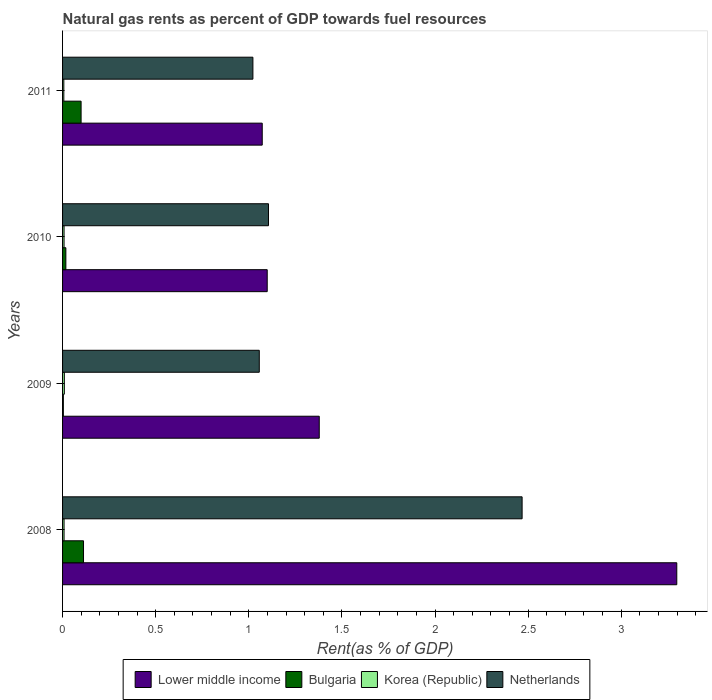How many groups of bars are there?
Offer a terse response. 4. Are the number of bars per tick equal to the number of legend labels?
Give a very brief answer. Yes. Are the number of bars on each tick of the Y-axis equal?
Give a very brief answer. Yes. How many bars are there on the 1st tick from the bottom?
Provide a short and direct response. 4. What is the matural gas rent in Bulgaria in 2009?
Your answer should be compact. 0. Across all years, what is the maximum matural gas rent in Lower middle income?
Make the answer very short. 3.3. Across all years, what is the minimum matural gas rent in Bulgaria?
Your answer should be very brief. 0. In which year was the matural gas rent in Korea (Republic) minimum?
Your answer should be compact. 2011. What is the total matural gas rent in Korea (Republic) in the graph?
Your answer should be compact. 0.03. What is the difference between the matural gas rent in Bulgaria in 2008 and that in 2011?
Keep it short and to the point. 0.01. What is the difference between the matural gas rent in Bulgaria in 2010 and the matural gas rent in Lower middle income in 2009?
Your answer should be very brief. -1.36. What is the average matural gas rent in Bulgaria per year?
Give a very brief answer. 0.06. In the year 2008, what is the difference between the matural gas rent in Lower middle income and matural gas rent in Netherlands?
Ensure brevity in your answer.  0.83. In how many years, is the matural gas rent in Netherlands greater than 1.6 %?
Ensure brevity in your answer.  1. What is the ratio of the matural gas rent in Netherlands in 2008 to that in 2009?
Your answer should be compact. 2.34. What is the difference between the highest and the second highest matural gas rent in Korea (Republic)?
Make the answer very short. 0. What is the difference between the highest and the lowest matural gas rent in Bulgaria?
Make the answer very short. 0.11. What does the 3rd bar from the bottom in 2009 represents?
Offer a terse response. Korea (Republic). Is it the case that in every year, the sum of the matural gas rent in Bulgaria and matural gas rent in Netherlands is greater than the matural gas rent in Lower middle income?
Your response must be concise. No. How many bars are there?
Your answer should be compact. 16. Are all the bars in the graph horizontal?
Your answer should be very brief. Yes. Are the values on the major ticks of X-axis written in scientific E-notation?
Make the answer very short. No. Does the graph contain any zero values?
Offer a very short reply. No. Where does the legend appear in the graph?
Offer a very short reply. Bottom center. How many legend labels are there?
Your response must be concise. 4. What is the title of the graph?
Provide a short and direct response. Natural gas rents as percent of GDP towards fuel resources. What is the label or title of the X-axis?
Keep it short and to the point. Rent(as % of GDP). What is the label or title of the Y-axis?
Your response must be concise. Years. What is the Rent(as % of GDP) of Lower middle income in 2008?
Your answer should be compact. 3.3. What is the Rent(as % of GDP) of Bulgaria in 2008?
Your answer should be compact. 0.11. What is the Rent(as % of GDP) in Korea (Republic) in 2008?
Your answer should be very brief. 0.01. What is the Rent(as % of GDP) in Netherlands in 2008?
Your answer should be very brief. 2.47. What is the Rent(as % of GDP) of Lower middle income in 2009?
Make the answer very short. 1.38. What is the Rent(as % of GDP) in Bulgaria in 2009?
Keep it short and to the point. 0. What is the Rent(as % of GDP) of Korea (Republic) in 2009?
Offer a terse response. 0.01. What is the Rent(as % of GDP) of Netherlands in 2009?
Make the answer very short. 1.06. What is the Rent(as % of GDP) of Lower middle income in 2010?
Provide a succinct answer. 1.1. What is the Rent(as % of GDP) in Bulgaria in 2010?
Your answer should be compact. 0.02. What is the Rent(as % of GDP) of Korea (Republic) in 2010?
Your response must be concise. 0.01. What is the Rent(as % of GDP) of Netherlands in 2010?
Ensure brevity in your answer.  1.11. What is the Rent(as % of GDP) in Lower middle income in 2011?
Provide a succinct answer. 1.07. What is the Rent(as % of GDP) in Bulgaria in 2011?
Keep it short and to the point. 0.1. What is the Rent(as % of GDP) in Korea (Republic) in 2011?
Make the answer very short. 0.01. What is the Rent(as % of GDP) in Netherlands in 2011?
Offer a terse response. 1.02. Across all years, what is the maximum Rent(as % of GDP) in Lower middle income?
Ensure brevity in your answer.  3.3. Across all years, what is the maximum Rent(as % of GDP) of Bulgaria?
Your answer should be very brief. 0.11. Across all years, what is the maximum Rent(as % of GDP) of Korea (Republic)?
Offer a very short reply. 0.01. Across all years, what is the maximum Rent(as % of GDP) of Netherlands?
Provide a short and direct response. 2.47. Across all years, what is the minimum Rent(as % of GDP) in Lower middle income?
Your answer should be very brief. 1.07. Across all years, what is the minimum Rent(as % of GDP) of Bulgaria?
Your answer should be very brief. 0. Across all years, what is the minimum Rent(as % of GDP) in Korea (Republic)?
Offer a terse response. 0.01. Across all years, what is the minimum Rent(as % of GDP) in Netherlands?
Your answer should be compact. 1.02. What is the total Rent(as % of GDP) in Lower middle income in the graph?
Ensure brevity in your answer.  6.85. What is the total Rent(as % of GDP) in Bulgaria in the graph?
Give a very brief answer. 0.23. What is the total Rent(as % of GDP) in Korea (Republic) in the graph?
Keep it short and to the point. 0.03. What is the total Rent(as % of GDP) of Netherlands in the graph?
Offer a very short reply. 5.65. What is the difference between the Rent(as % of GDP) of Lower middle income in 2008 and that in 2009?
Your answer should be very brief. 1.92. What is the difference between the Rent(as % of GDP) in Bulgaria in 2008 and that in 2009?
Provide a succinct answer. 0.11. What is the difference between the Rent(as % of GDP) of Korea (Republic) in 2008 and that in 2009?
Your answer should be very brief. -0. What is the difference between the Rent(as % of GDP) of Netherlands in 2008 and that in 2009?
Provide a short and direct response. 1.41. What is the difference between the Rent(as % of GDP) of Lower middle income in 2008 and that in 2010?
Provide a succinct answer. 2.2. What is the difference between the Rent(as % of GDP) of Bulgaria in 2008 and that in 2010?
Your answer should be very brief. 0.09. What is the difference between the Rent(as % of GDP) in Netherlands in 2008 and that in 2010?
Ensure brevity in your answer.  1.36. What is the difference between the Rent(as % of GDP) of Lower middle income in 2008 and that in 2011?
Your answer should be very brief. 2.23. What is the difference between the Rent(as % of GDP) in Bulgaria in 2008 and that in 2011?
Give a very brief answer. 0.01. What is the difference between the Rent(as % of GDP) in Korea (Republic) in 2008 and that in 2011?
Provide a succinct answer. 0. What is the difference between the Rent(as % of GDP) in Netherlands in 2008 and that in 2011?
Keep it short and to the point. 1.45. What is the difference between the Rent(as % of GDP) in Lower middle income in 2009 and that in 2010?
Make the answer very short. 0.28. What is the difference between the Rent(as % of GDP) of Bulgaria in 2009 and that in 2010?
Offer a terse response. -0.01. What is the difference between the Rent(as % of GDP) of Korea (Republic) in 2009 and that in 2010?
Provide a succinct answer. 0. What is the difference between the Rent(as % of GDP) of Netherlands in 2009 and that in 2010?
Your answer should be very brief. -0.05. What is the difference between the Rent(as % of GDP) of Lower middle income in 2009 and that in 2011?
Provide a succinct answer. 0.31. What is the difference between the Rent(as % of GDP) of Bulgaria in 2009 and that in 2011?
Your answer should be very brief. -0.1. What is the difference between the Rent(as % of GDP) in Korea (Republic) in 2009 and that in 2011?
Give a very brief answer. 0. What is the difference between the Rent(as % of GDP) of Netherlands in 2009 and that in 2011?
Ensure brevity in your answer.  0.03. What is the difference between the Rent(as % of GDP) of Lower middle income in 2010 and that in 2011?
Give a very brief answer. 0.03. What is the difference between the Rent(as % of GDP) in Bulgaria in 2010 and that in 2011?
Your answer should be compact. -0.08. What is the difference between the Rent(as % of GDP) in Korea (Republic) in 2010 and that in 2011?
Offer a very short reply. 0. What is the difference between the Rent(as % of GDP) of Netherlands in 2010 and that in 2011?
Provide a succinct answer. 0.08. What is the difference between the Rent(as % of GDP) of Lower middle income in 2008 and the Rent(as % of GDP) of Bulgaria in 2009?
Your answer should be compact. 3.29. What is the difference between the Rent(as % of GDP) of Lower middle income in 2008 and the Rent(as % of GDP) of Korea (Republic) in 2009?
Offer a very short reply. 3.29. What is the difference between the Rent(as % of GDP) of Lower middle income in 2008 and the Rent(as % of GDP) of Netherlands in 2009?
Make the answer very short. 2.24. What is the difference between the Rent(as % of GDP) of Bulgaria in 2008 and the Rent(as % of GDP) of Korea (Republic) in 2009?
Give a very brief answer. 0.1. What is the difference between the Rent(as % of GDP) of Bulgaria in 2008 and the Rent(as % of GDP) of Netherlands in 2009?
Ensure brevity in your answer.  -0.94. What is the difference between the Rent(as % of GDP) in Korea (Republic) in 2008 and the Rent(as % of GDP) in Netherlands in 2009?
Offer a terse response. -1.05. What is the difference between the Rent(as % of GDP) in Lower middle income in 2008 and the Rent(as % of GDP) in Bulgaria in 2010?
Your response must be concise. 3.28. What is the difference between the Rent(as % of GDP) of Lower middle income in 2008 and the Rent(as % of GDP) of Korea (Republic) in 2010?
Ensure brevity in your answer.  3.29. What is the difference between the Rent(as % of GDP) of Lower middle income in 2008 and the Rent(as % of GDP) of Netherlands in 2010?
Ensure brevity in your answer.  2.19. What is the difference between the Rent(as % of GDP) in Bulgaria in 2008 and the Rent(as % of GDP) in Korea (Republic) in 2010?
Offer a very short reply. 0.1. What is the difference between the Rent(as % of GDP) of Bulgaria in 2008 and the Rent(as % of GDP) of Netherlands in 2010?
Provide a short and direct response. -0.99. What is the difference between the Rent(as % of GDP) in Korea (Republic) in 2008 and the Rent(as % of GDP) in Netherlands in 2010?
Keep it short and to the point. -1.1. What is the difference between the Rent(as % of GDP) of Lower middle income in 2008 and the Rent(as % of GDP) of Bulgaria in 2011?
Keep it short and to the point. 3.2. What is the difference between the Rent(as % of GDP) in Lower middle income in 2008 and the Rent(as % of GDP) in Korea (Republic) in 2011?
Provide a short and direct response. 3.29. What is the difference between the Rent(as % of GDP) in Lower middle income in 2008 and the Rent(as % of GDP) in Netherlands in 2011?
Give a very brief answer. 2.28. What is the difference between the Rent(as % of GDP) in Bulgaria in 2008 and the Rent(as % of GDP) in Korea (Republic) in 2011?
Your response must be concise. 0.11. What is the difference between the Rent(as % of GDP) in Bulgaria in 2008 and the Rent(as % of GDP) in Netherlands in 2011?
Offer a very short reply. -0.91. What is the difference between the Rent(as % of GDP) of Korea (Republic) in 2008 and the Rent(as % of GDP) of Netherlands in 2011?
Give a very brief answer. -1.01. What is the difference between the Rent(as % of GDP) of Lower middle income in 2009 and the Rent(as % of GDP) of Bulgaria in 2010?
Your answer should be very brief. 1.36. What is the difference between the Rent(as % of GDP) of Lower middle income in 2009 and the Rent(as % of GDP) of Korea (Republic) in 2010?
Give a very brief answer. 1.37. What is the difference between the Rent(as % of GDP) in Lower middle income in 2009 and the Rent(as % of GDP) in Netherlands in 2010?
Keep it short and to the point. 0.27. What is the difference between the Rent(as % of GDP) in Bulgaria in 2009 and the Rent(as % of GDP) in Korea (Republic) in 2010?
Your response must be concise. -0. What is the difference between the Rent(as % of GDP) in Bulgaria in 2009 and the Rent(as % of GDP) in Netherlands in 2010?
Offer a very short reply. -1.1. What is the difference between the Rent(as % of GDP) in Korea (Republic) in 2009 and the Rent(as % of GDP) in Netherlands in 2010?
Your answer should be compact. -1.1. What is the difference between the Rent(as % of GDP) in Lower middle income in 2009 and the Rent(as % of GDP) in Bulgaria in 2011?
Make the answer very short. 1.28. What is the difference between the Rent(as % of GDP) of Lower middle income in 2009 and the Rent(as % of GDP) of Korea (Republic) in 2011?
Your response must be concise. 1.37. What is the difference between the Rent(as % of GDP) in Lower middle income in 2009 and the Rent(as % of GDP) in Netherlands in 2011?
Give a very brief answer. 0.36. What is the difference between the Rent(as % of GDP) in Bulgaria in 2009 and the Rent(as % of GDP) in Korea (Republic) in 2011?
Offer a terse response. -0. What is the difference between the Rent(as % of GDP) in Bulgaria in 2009 and the Rent(as % of GDP) in Netherlands in 2011?
Offer a very short reply. -1.02. What is the difference between the Rent(as % of GDP) of Korea (Republic) in 2009 and the Rent(as % of GDP) of Netherlands in 2011?
Make the answer very short. -1.01. What is the difference between the Rent(as % of GDP) in Lower middle income in 2010 and the Rent(as % of GDP) in Bulgaria in 2011?
Provide a succinct answer. 1. What is the difference between the Rent(as % of GDP) of Lower middle income in 2010 and the Rent(as % of GDP) of Korea (Republic) in 2011?
Provide a succinct answer. 1.09. What is the difference between the Rent(as % of GDP) in Lower middle income in 2010 and the Rent(as % of GDP) in Netherlands in 2011?
Your response must be concise. 0.08. What is the difference between the Rent(as % of GDP) in Bulgaria in 2010 and the Rent(as % of GDP) in Korea (Republic) in 2011?
Ensure brevity in your answer.  0.01. What is the difference between the Rent(as % of GDP) of Bulgaria in 2010 and the Rent(as % of GDP) of Netherlands in 2011?
Keep it short and to the point. -1. What is the difference between the Rent(as % of GDP) of Korea (Republic) in 2010 and the Rent(as % of GDP) of Netherlands in 2011?
Provide a succinct answer. -1.01. What is the average Rent(as % of GDP) of Lower middle income per year?
Offer a very short reply. 1.71. What is the average Rent(as % of GDP) of Bulgaria per year?
Keep it short and to the point. 0.06. What is the average Rent(as % of GDP) of Korea (Republic) per year?
Offer a very short reply. 0.01. What is the average Rent(as % of GDP) of Netherlands per year?
Offer a very short reply. 1.41. In the year 2008, what is the difference between the Rent(as % of GDP) of Lower middle income and Rent(as % of GDP) of Bulgaria?
Your answer should be compact. 3.19. In the year 2008, what is the difference between the Rent(as % of GDP) of Lower middle income and Rent(as % of GDP) of Korea (Republic)?
Make the answer very short. 3.29. In the year 2008, what is the difference between the Rent(as % of GDP) in Lower middle income and Rent(as % of GDP) in Netherlands?
Your response must be concise. 0.83. In the year 2008, what is the difference between the Rent(as % of GDP) of Bulgaria and Rent(as % of GDP) of Korea (Republic)?
Your answer should be very brief. 0.1. In the year 2008, what is the difference between the Rent(as % of GDP) of Bulgaria and Rent(as % of GDP) of Netherlands?
Keep it short and to the point. -2.36. In the year 2008, what is the difference between the Rent(as % of GDP) in Korea (Republic) and Rent(as % of GDP) in Netherlands?
Offer a terse response. -2.46. In the year 2009, what is the difference between the Rent(as % of GDP) in Lower middle income and Rent(as % of GDP) in Bulgaria?
Your answer should be very brief. 1.37. In the year 2009, what is the difference between the Rent(as % of GDP) in Lower middle income and Rent(as % of GDP) in Korea (Republic)?
Provide a short and direct response. 1.37. In the year 2009, what is the difference between the Rent(as % of GDP) of Lower middle income and Rent(as % of GDP) of Netherlands?
Keep it short and to the point. 0.32. In the year 2009, what is the difference between the Rent(as % of GDP) in Bulgaria and Rent(as % of GDP) in Korea (Republic)?
Ensure brevity in your answer.  -0.01. In the year 2009, what is the difference between the Rent(as % of GDP) in Bulgaria and Rent(as % of GDP) in Netherlands?
Your answer should be very brief. -1.05. In the year 2009, what is the difference between the Rent(as % of GDP) in Korea (Republic) and Rent(as % of GDP) in Netherlands?
Ensure brevity in your answer.  -1.05. In the year 2010, what is the difference between the Rent(as % of GDP) of Lower middle income and Rent(as % of GDP) of Bulgaria?
Provide a short and direct response. 1.08. In the year 2010, what is the difference between the Rent(as % of GDP) of Lower middle income and Rent(as % of GDP) of Netherlands?
Keep it short and to the point. -0.01. In the year 2010, what is the difference between the Rent(as % of GDP) in Bulgaria and Rent(as % of GDP) in Korea (Republic)?
Give a very brief answer. 0.01. In the year 2010, what is the difference between the Rent(as % of GDP) in Bulgaria and Rent(as % of GDP) in Netherlands?
Provide a short and direct response. -1.09. In the year 2010, what is the difference between the Rent(as % of GDP) of Korea (Republic) and Rent(as % of GDP) of Netherlands?
Provide a succinct answer. -1.1. In the year 2011, what is the difference between the Rent(as % of GDP) in Lower middle income and Rent(as % of GDP) in Bulgaria?
Your answer should be compact. 0.97. In the year 2011, what is the difference between the Rent(as % of GDP) in Lower middle income and Rent(as % of GDP) in Korea (Republic)?
Your response must be concise. 1.07. In the year 2011, what is the difference between the Rent(as % of GDP) in Lower middle income and Rent(as % of GDP) in Netherlands?
Provide a short and direct response. 0.05. In the year 2011, what is the difference between the Rent(as % of GDP) in Bulgaria and Rent(as % of GDP) in Korea (Republic)?
Offer a very short reply. 0.09. In the year 2011, what is the difference between the Rent(as % of GDP) in Bulgaria and Rent(as % of GDP) in Netherlands?
Provide a succinct answer. -0.92. In the year 2011, what is the difference between the Rent(as % of GDP) in Korea (Republic) and Rent(as % of GDP) in Netherlands?
Provide a short and direct response. -1.02. What is the ratio of the Rent(as % of GDP) of Lower middle income in 2008 to that in 2009?
Your response must be concise. 2.39. What is the ratio of the Rent(as % of GDP) in Bulgaria in 2008 to that in 2009?
Your answer should be compact. 26.83. What is the ratio of the Rent(as % of GDP) in Korea (Republic) in 2008 to that in 2009?
Your answer should be compact. 0.84. What is the ratio of the Rent(as % of GDP) in Netherlands in 2008 to that in 2009?
Offer a terse response. 2.34. What is the ratio of the Rent(as % of GDP) in Lower middle income in 2008 to that in 2010?
Your response must be concise. 3. What is the ratio of the Rent(as % of GDP) of Bulgaria in 2008 to that in 2010?
Your response must be concise. 6.36. What is the ratio of the Rent(as % of GDP) in Korea (Republic) in 2008 to that in 2010?
Ensure brevity in your answer.  0.99. What is the ratio of the Rent(as % of GDP) of Netherlands in 2008 to that in 2010?
Give a very brief answer. 2.23. What is the ratio of the Rent(as % of GDP) in Lower middle income in 2008 to that in 2011?
Give a very brief answer. 3.08. What is the ratio of the Rent(as % of GDP) of Bulgaria in 2008 to that in 2011?
Your answer should be very brief. 1.13. What is the ratio of the Rent(as % of GDP) of Korea (Republic) in 2008 to that in 2011?
Keep it short and to the point. 1.18. What is the ratio of the Rent(as % of GDP) of Netherlands in 2008 to that in 2011?
Your response must be concise. 2.41. What is the ratio of the Rent(as % of GDP) in Lower middle income in 2009 to that in 2010?
Your answer should be very brief. 1.25. What is the ratio of the Rent(as % of GDP) in Bulgaria in 2009 to that in 2010?
Provide a short and direct response. 0.24. What is the ratio of the Rent(as % of GDP) of Korea (Republic) in 2009 to that in 2010?
Make the answer very short. 1.19. What is the ratio of the Rent(as % of GDP) in Netherlands in 2009 to that in 2010?
Your answer should be compact. 0.96. What is the ratio of the Rent(as % of GDP) of Lower middle income in 2009 to that in 2011?
Provide a short and direct response. 1.29. What is the ratio of the Rent(as % of GDP) in Bulgaria in 2009 to that in 2011?
Ensure brevity in your answer.  0.04. What is the ratio of the Rent(as % of GDP) in Korea (Republic) in 2009 to that in 2011?
Offer a very short reply. 1.41. What is the ratio of the Rent(as % of GDP) of Netherlands in 2009 to that in 2011?
Offer a terse response. 1.03. What is the ratio of the Rent(as % of GDP) of Lower middle income in 2010 to that in 2011?
Provide a succinct answer. 1.02. What is the ratio of the Rent(as % of GDP) in Bulgaria in 2010 to that in 2011?
Ensure brevity in your answer.  0.18. What is the ratio of the Rent(as % of GDP) in Korea (Republic) in 2010 to that in 2011?
Keep it short and to the point. 1.18. What is the ratio of the Rent(as % of GDP) in Netherlands in 2010 to that in 2011?
Your response must be concise. 1.08. What is the difference between the highest and the second highest Rent(as % of GDP) in Lower middle income?
Your answer should be very brief. 1.92. What is the difference between the highest and the second highest Rent(as % of GDP) of Bulgaria?
Make the answer very short. 0.01. What is the difference between the highest and the second highest Rent(as % of GDP) of Korea (Republic)?
Keep it short and to the point. 0. What is the difference between the highest and the second highest Rent(as % of GDP) of Netherlands?
Your answer should be compact. 1.36. What is the difference between the highest and the lowest Rent(as % of GDP) in Lower middle income?
Ensure brevity in your answer.  2.23. What is the difference between the highest and the lowest Rent(as % of GDP) in Bulgaria?
Your answer should be very brief. 0.11. What is the difference between the highest and the lowest Rent(as % of GDP) in Korea (Republic)?
Your answer should be compact. 0. What is the difference between the highest and the lowest Rent(as % of GDP) in Netherlands?
Keep it short and to the point. 1.45. 